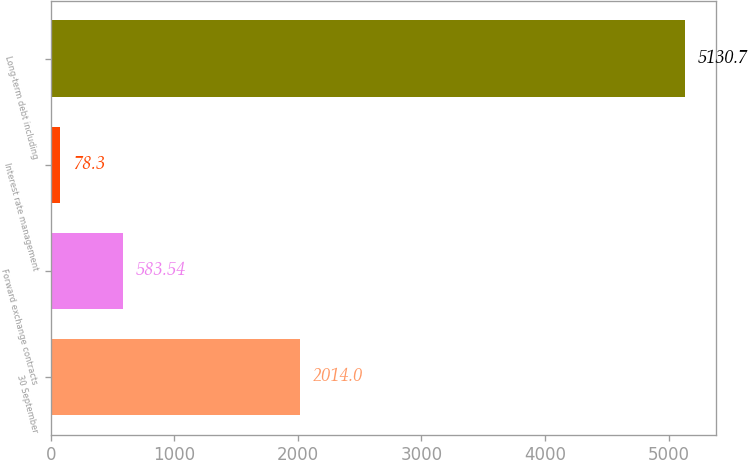<chart> <loc_0><loc_0><loc_500><loc_500><bar_chart><fcel>30 September<fcel>Forward exchange contracts<fcel>Interest rate management<fcel>Long-term debt including<nl><fcel>2014<fcel>583.54<fcel>78.3<fcel>5130.7<nl></chart> 